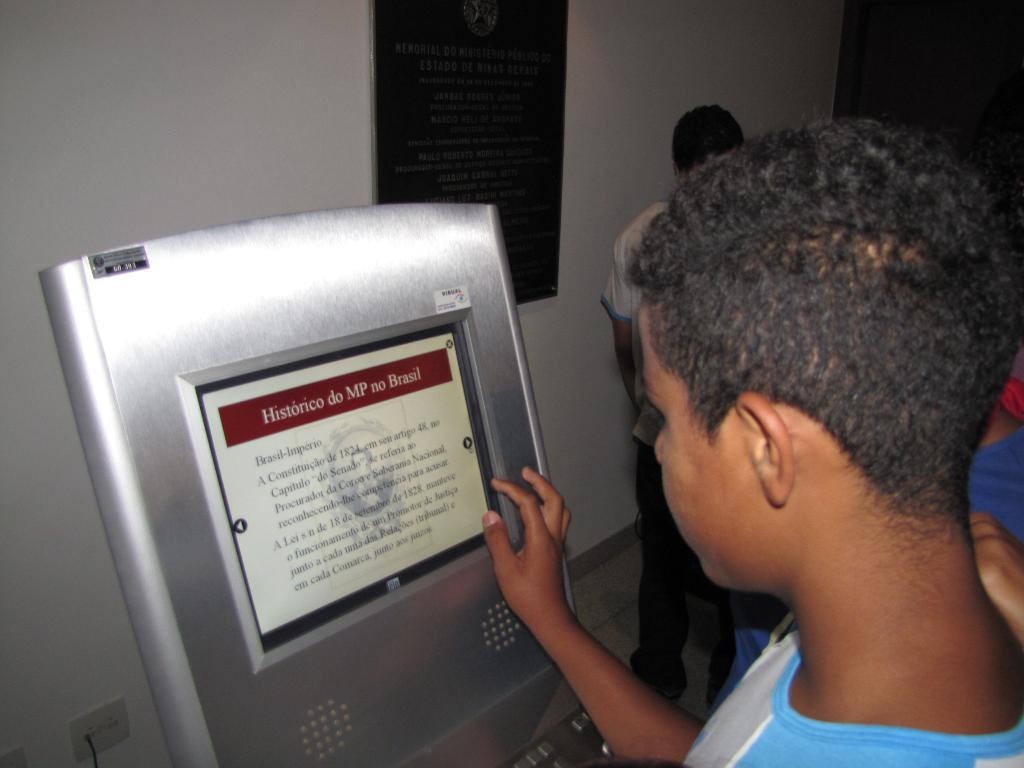How many people are in the image? There are people standing in the image, but the exact number is not specified. What is in front of the people? There is a board in front of the people. What can be seen on the board? Something is written on the board. What is attached to the wall at the back side of the image? There is a black color board attached to the wall. How does the butter fall from the sky in the image? There is no butter or any falling objects in the image. 